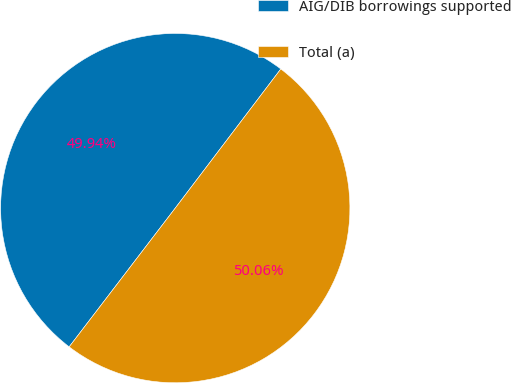<chart> <loc_0><loc_0><loc_500><loc_500><pie_chart><fcel>AIG/DIB borrowings supported<fcel>Total (a)<nl><fcel>49.94%<fcel>50.06%<nl></chart> 